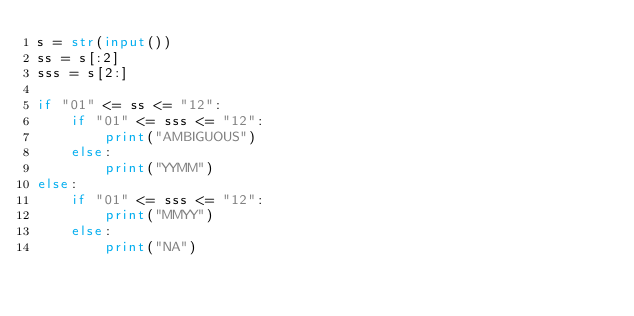<code> <loc_0><loc_0><loc_500><loc_500><_Python_>s = str(input())
ss = s[:2]
sss = s[2:]

if "01" <= ss <= "12":
    if "01" <= sss <= "12":
        print("AMBIGUOUS")
    else:
        print("YYMM")
else:
    if "01" <= sss <= "12":
        print("MMYY")
    else:
        print("NA")</code> 